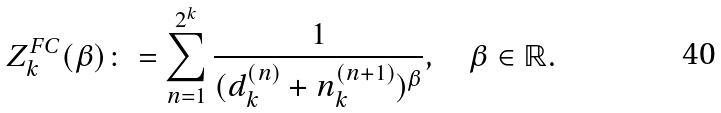<formula> <loc_0><loc_0><loc_500><loc_500>Z _ { k } ^ { F C } ( \beta ) \colon = \sum _ { n = 1 } ^ { 2 ^ { k } } \frac { 1 } { ( d _ { k } ^ { ( n ) } + n _ { k } ^ { ( n + 1 ) } ) ^ { \beta } } , \quad \beta \in \mathbb { R } .</formula> 